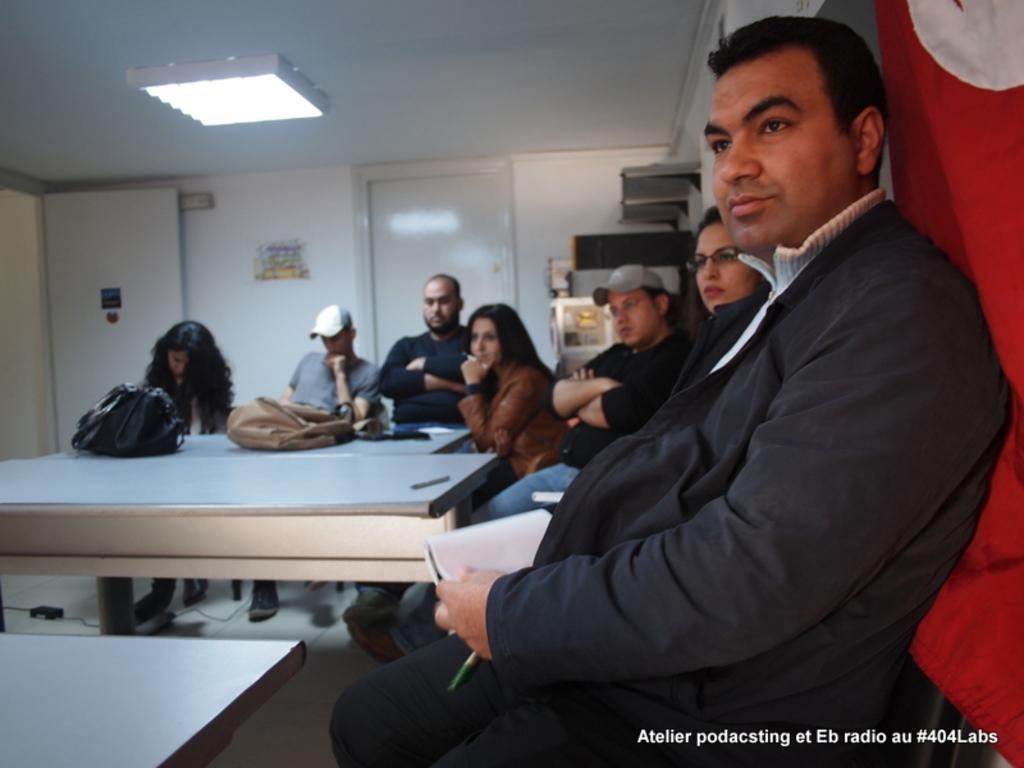How would you summarize this image in a sentence or two? In a room there are people sitting on the chairs and in front of the tables and on the tables there are two bags and one pen and behind the people there is a wall and two doors and at the corner of the room there are some shelves and things on them. 